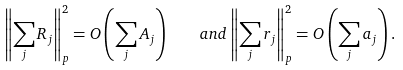Convert formula to latex. <formula><loc_0><loc_0><loc_500><loc_500>\left \| \sum _ { j } R _ { j } \right \| ^ { 2 } _ { p } = O \left ( \sum _ { j } A _ { j } \right ) \quad a n d \left \| \sum _ { j } r _ { j } \right \| ^ { 2 } _ { p } = O \left ( \sum _ { j } a _ { j } \right ) .</formula> 